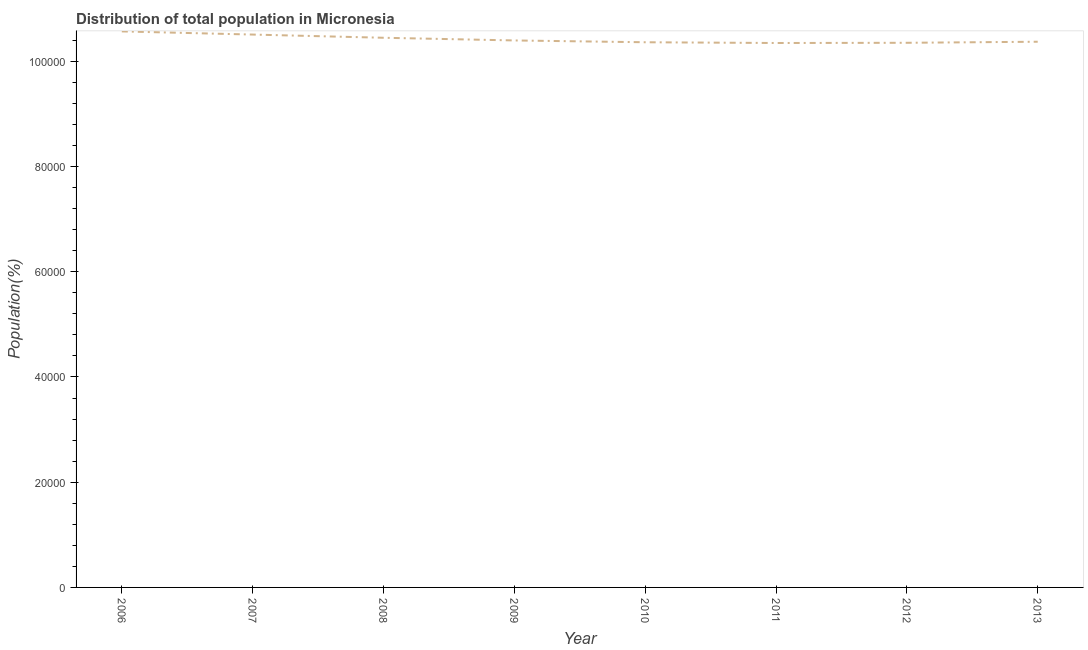What is the population in 2011?
Offer a very short reply. 1.03e+05. Across all years, what is the maximum population?
Ensure brevity in your answer.  1.06e+05. Across all years, what is the minimum population?
Your response must be concise. 1.03e+05. In which year was the population maximum?
Offer a terse response. 2006. In which year was the population minimum?
Provide a short and direct response. 2011. What is the sum of the population?
Keep it short and to the point. 8.34e+05. What is the difference between the population in 2007 and 2009?
Your answer should be compact. 1119. What is the average population per year?
Provide a short and direct response. 1.04e+05. What is the median population?
Your answer should be very brief. 1.04e+05. In how many years, is the population greater than 32000 %?
Your answer should be compact. 8. What is the ratio of the population in 2007 to that in 2011?
Your answer should be very brief. 1.02. Is the population in 2007 less than that in 2009?
Keep it short and to the point. No. What is the difference between the highest and the second highest population?
Ensure brevity in your answer.  600. What is the difference between the highest and the lowest population?
Keep it short and to the point. 2204. Does the population monotonically increase over the years?
Keep it short and to the point. No. How many years are there in the graph?
Your answer should be very brief. 8. What is the difference between two consecutive major ticks on the Y-axis?
Offer a terse response. 2.00e+04. Are the values on the major ticks of Y-axis written in scientific E-notation?
Provide a succinct answer. No. Does the graph contain any zero values?
Provide a succinct answer. No. Does the graph contain grids?
Provide a succinct answer. No. What is the title of the graph?
Your answer should be compact. Distribution of total population in Micronesia . What is the label or title of the X-axis?
Make the answer very short. Year. What is the label or title of the Y-axis?
Make the answer very short. Population(%). What is the Population(%) in 2006?
Your response must be concise. 1.06e+05. What is the Population(%) in 2007?
Ensure brevity in your answer.  1.05e+05. What is the Population(%) in 2008?
Your response must be concise. 1.04e+05. What is the Population(%) in 2009?
Your answer should be compact. 1.04e+05. What is the Population(%) of 2010?
Give a very brief answer. 1.04e+05. What is the Population(%) of 2011?
Keep it short and to the point. 1.03e+05. What is the Population(%) of 2012?
Ensure brevity in your answer.  1.04e+05. What is the Population(%) of 2013?
Your answer should be compact. 1.04e+05. What is the difference between the Population(%) in 2006 and 2007?
Your answer should be compact. 600. What is the difference between the Population(%) in 2006 and 2008?
Offer a terse response. 1208. What is the difference between the Population(%) in 2006 and 2009?
Give a very brief answer. 1719. What is the difference between the Population(%) in 2006 and 2010?
Provide a short and direct response. 2061. What is the difference between the Population(%) in 2006 and 2011?
Your response must be concise. 2204. What is the difference between the Population(%) in 2006 and 2012?
Ensure brevity in your answer.  2164. What is the difference between the Population(%) in 2006 and 2013?
Offer a very short reply. 1962. What is the difference between the Population(%) in 2007 and 2008?
Give a very brief answer. 608. What is the difference between the Population(%) in 2007 and 2009?
Ensure brevity in your answer.  1119. What is the difference between the Population(%) in 2007 and 2010?
Give a very brief answer. 1461. What is the difference between the Population(%) in 2007 and 2011?
Offer a terse response. 1604. What is the difference between the Population(%) in 2007 and 2012?
Your answer should be very brief. 1564. What is the difference between the Population(%) in 2007 and 2013?
Offer a terse response. 1362. What is the difference between the Population(%) in 2008 and 2009?
Keep it short and to the point. 511. What is the difference between the Population(%) in 2008 and 2010?
Your response must be concise. 853. What is the difference between the Population(%) in 2008 and 2011?
Offer a terse response. 996. What is the difference between the Population(%) in 2008 and 2012?
Your response must be concise. 956. What is the difference between the Population(%) in 2008 and 2013?
Provide a succinct answer. 754. What is the difference between the Population(%) in 2009 and 2010?
Give a very brief answer. 342. What is the difference between the Population(%) in 2009 and 2011?
Give a very brief answer. 485. What is the difference between the Population(%) in 2009 and 2012?
Provide a succinct answer. 445. What is the difference between the Population(%) in 2009 and 2013?
Ensure brevity in your answer.  243. What is the difference between the Population(%) in 2010 and 2011?
Your answer should be compact. 143. What is the difference between the Population(%) in 2010 and 2012?
Ensure brevity in your answer.  103. What is the difference between the Population(%) in 2010 and 2013?
Offer a terse response. -99. What is the difference between the Population(%) in 2011 and 2012?
Provide a short and direct response. -40. What is the difference between the Population(%) in 2011 and 2013?
Make the answer very short. -242. What is the difference between the Population(%) in 2012 and 2013?
Your response must be concise. -202. What is the ratio of the Population(%) in 2006 to that in 2009?
Provide a succinct answer. 1.02. What is the ratio of the Population(%) in 2006 to that in 2012?
Offer a very short reply. 1.02. What is the ratio of the Population(%) in 2006 to that in 2013?
Keep it short and to the point. 1.02. What is the ratio of the Population(%) in 2007 to that in 2010?
Your response must be concise. 1.01. What is the ratio of the Population(%) in 2007 to that in 2012?
Provide a short and direct response. 1.01. What is the ratio of the Population(%) in 2008 to that in 2009?
Offer a terse response. 1. What is the ratio of the Population(%) in 2009 to that in 2010?
Provide a short and direct response. 1. What is the ratio of the Population(%) in 2009 to that in 2012?
Provide a succinct answer. 1. What is the ratio of the Population(%) in 2009 to that in 2013?
Offer a terse response. 1. What is the ratio of the Population(%) in 2010 to that in 2013?
Provide a succinct answer. 1. What is the ratio of the Population(%) in 2011 to that in 2012?
Provide a succinct answer. 1. What is the ratio of the Population(%) in 2012 to that in 2013?
Make the answer very short. 1. 